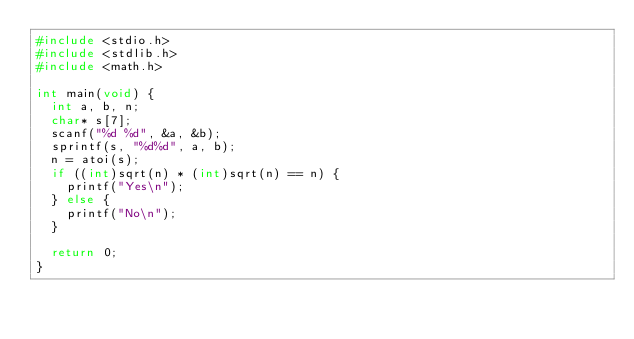<code> <loc_0><loc_0><loc_500><loc_500><_C_>#include <stdio.h>
#include <stdlib.h>
#include <math.h>

int main(void) {
  int a, b, n;
  char* s[7];
  scanf("%d %d", &a, &b);
  sprintf(s, "%d%d", a, b);
  n = atoi(s);
  if ((int)sqrt(n) * (int)sqrt(n) == n) {
    printf("Yes\n");
  } else {
    printf("No\n");
  }

  return 0;
}
</code> 